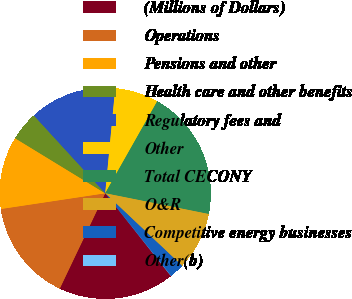Convert chart to OTSL. <chart><loc_0><loc_0><loc_500><loc_500><pie_chart><fcel>(Millions of Dollars)<fcel>Operations<fcel>Pensions and other<fcel>Health care and other benefits<fcel>Regulatory fees and<fcel>Other<fcel>Total CECONY<fcel>O&R<fcel>Competitive energy businesses<fcel>Other(b)<nl><fcel>17.75%<fcel>15.54%<fcel>11.11%<fcel>4.46%<fcel>13.32%<fcel>6.68%<fcel>19.96%<fcel>8.89%<fcel>2.25%<fcel>0.04%<nl></chart> 